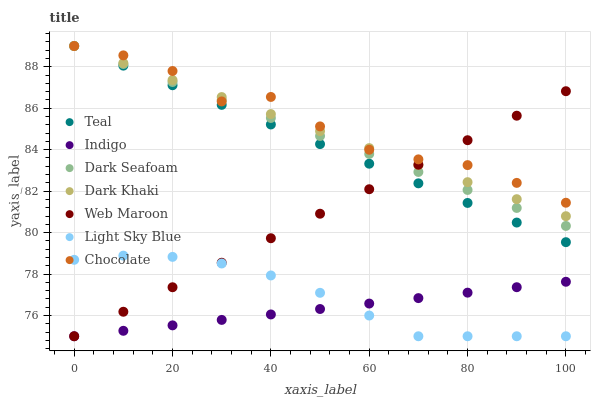Does Indigo have the minimum area under the curve?
Answer yes or no. Yes. Does Chocolate have the maximum area under the curve?
Answer yes or no. Yes. Does Web Maroon have the minimum area under the curve?
Answer yes or no. No. Does Web Maroon have the maximum area under the curve?
Answer yes or no. No. Is Indigo the smoothest?
Answer yes or no. Yes. Is Chocolate the roughest?
Answer yes or no. Yes. Is Web Maroon the smoothest?
Answer yes or no. No. Is Web Maroon the roughest?
Answer yes or no. No. Does Indigo have the lowest value?
Answer yes or no. Yes. Does Chocolate have the lowest value?
Answer yes or no. No. Does Teal have the highest value?
Answer yes or no. Yes. Does Web Maroon have the highest value?
Answer yes or no. No. Is Indigo less than Chocolate?
Answer yes or no. Yes. Is Dark Khaki greater than Light Sky Blue?
Answer yes or no. Yes. Does Web Maroon intersect Dark Khaki?
Answer yes or no. Yes. Is Web Maroon less than Dark Khaki?
Answer yes or no. No. Is Web Maroon greater than Dark Khaki?
Answer yes or no. No. Does Indigo intersect Chocolate?
Answer yes or no. No. 